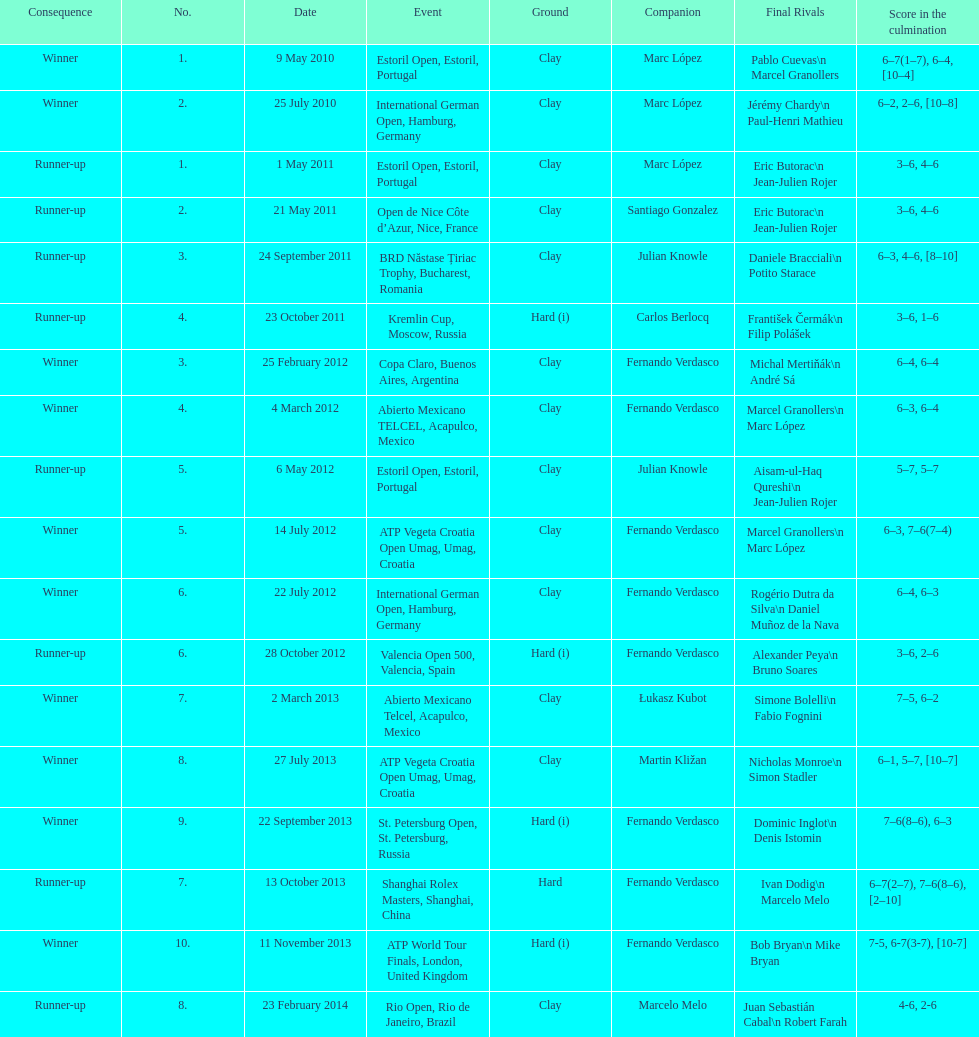What tournament was played after the kremlin cup? Copa Claro, Buenos Aires, Argentina. 